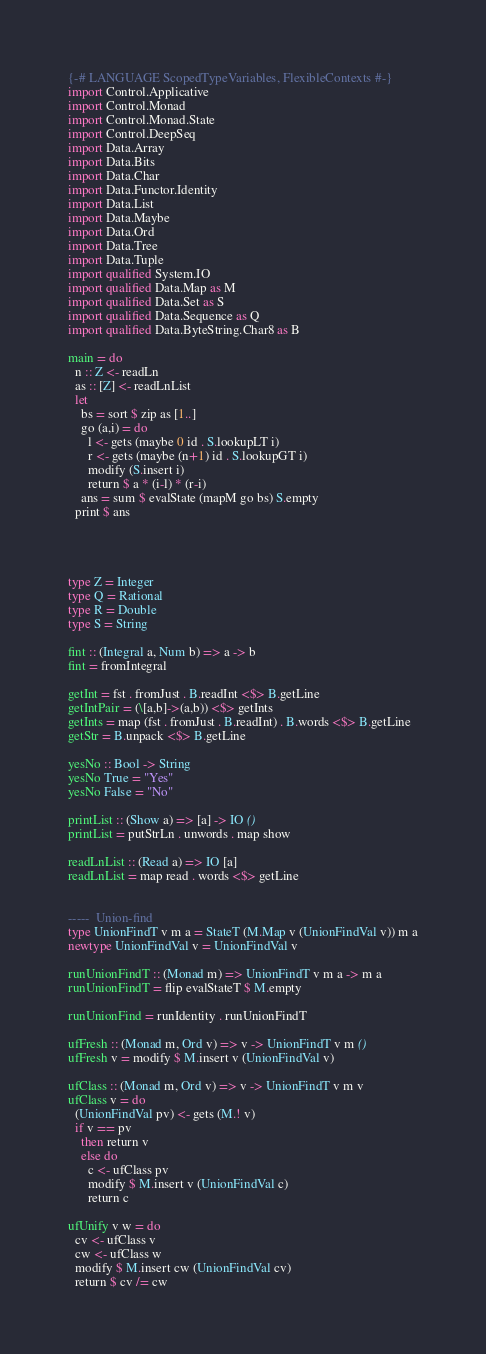<code> <loc_0><loc_0><loc_500><loc_500><_Haskell_>{-# LANGUAGE ScopedTypeVariables, FlexibleContexts #-}
import Control.Applicative
import Control.Monad
import Control.Monad.State
import Control.DeepSeq
import Data.Array
import Data.Bits
import Data.Char
import Data.Functor.Identity
import Data.List
import Data.Maybe
import Data.Ord
import Data.Tree
import Data.Tuple
import qualified System.IO
import qualified Data.Map as M
import qualified Data.Set as S
import qualified Data.Sequence as Q
import qualified Data.ByteString.Char8 as B

main = do
  n :: Z <- readLn
  as :: [Z] <- readLnList
  let
    bs = sort $ zip as [1..]
    go (a,i) = do
      l <- gets (maybe 0 id . S.lookupLT i)
      r <- gets (maybe (n+1) id . S.lookupGT i)
      modify (S.insert i)
      return $ a * (i-l) * (r-i)
    ans = sum $ evalState (mapM go bs) S.empty
  print $ ans



 
type Z = Integer
type Q = Rational
type R = Double
type S = String

fint :: (Integral a, Num b) => a -> b
fint = fromIntegral

getInt = fst . fromJust . B.readInt <$> B.getLine
getIntPair = (\[a,b]->(a,b)) <$> getInts
getInts = map (fst . fromJust . B.readInt) . B.words <$> B.getLine
getStr = B.unpack <$> B.getLine

yesNo :: Bool -> String
yesNo True = "Yes"
yesNo False = "No"

printList :: (Show a) => [a] -> IO ()
printList = putStrLn . unwords . map show

readLnList :: (Read a) => IO [a]
readLnList = map read . words <$> getLine


-----  Union-find
type UnionFindT v m a = StateT (M.Map v (UnionFindVal v)) m a
newtype UnionFindVal v = UnionFindVal v

runUnionFindT :: (Monad m) => UnionFindT v m a -> m a
runUnionFindT = flip evalStateT $ M.empty

runUnionFind = runIdentity . runUnionFindT

ufFresh :: (Monad m, Ord v) => v -> UnionFindT v m ()
ufFresh v = modify $ M.insert v (UnionFindVal v)

ufClass :: (Monad m, Ord v) => v -> UnionFindT v m v
ufClass v = do
  (UnionFindVal pv) <- gets (M.! v)
  if v == pv
    then return v
    else do
      c <- ufClass pv
      modify $ M.insert v (UnionFindVal c)
      return c

ufUnify v w = do
  cv <- ufClass v
  cw <- ufClass w
  modify $ M.insert cw (UnionFindVal cv)
  return $ cv /= cw
</code> 